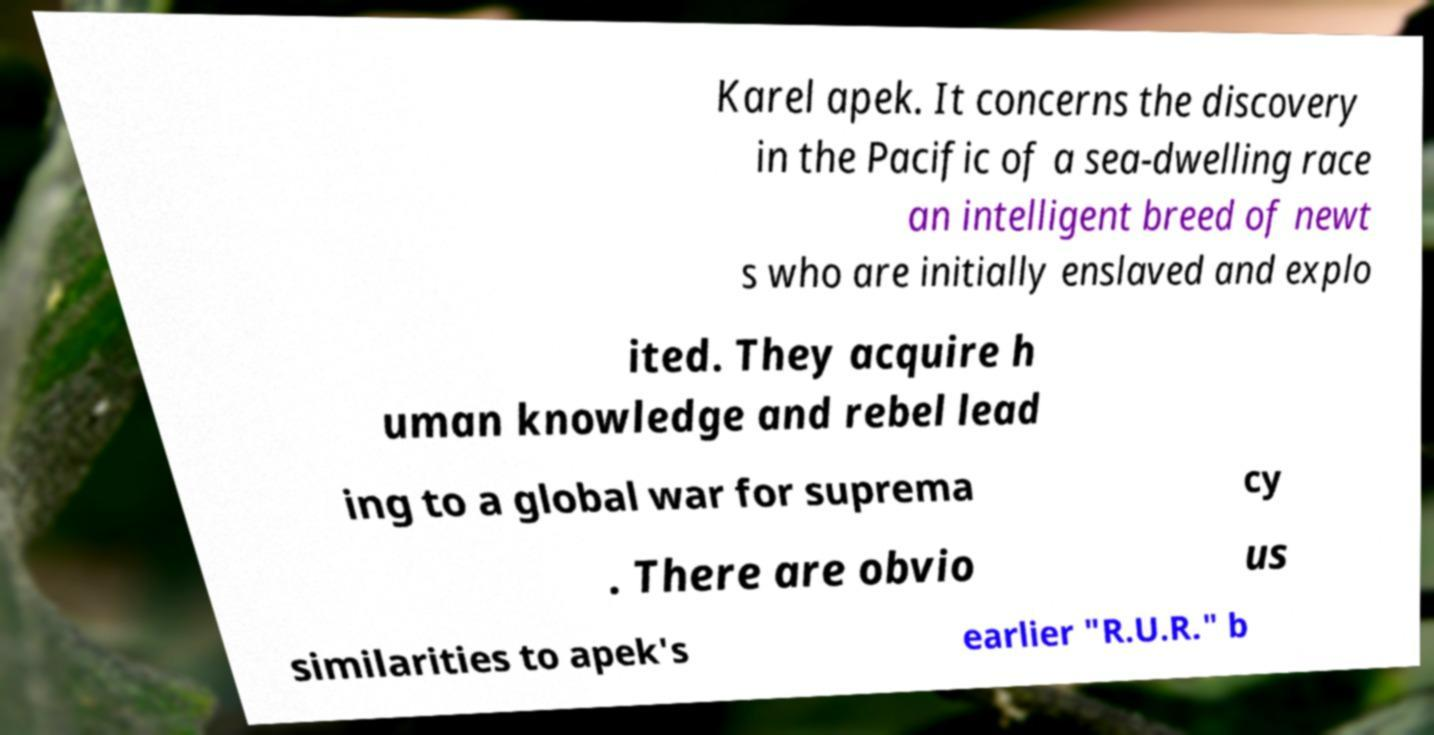Could you extract and type out the text from this image? Karel apek. It concerns the discovery in the Pacific of a sea-dwelling race an intelligent breed of newt s who are initially enslaved and explo ited. They acquire h uman knowledge and rebel lead ing to a global war for suprema cy . There are obvio us similarities to apek's earlier "R.U.R." b 